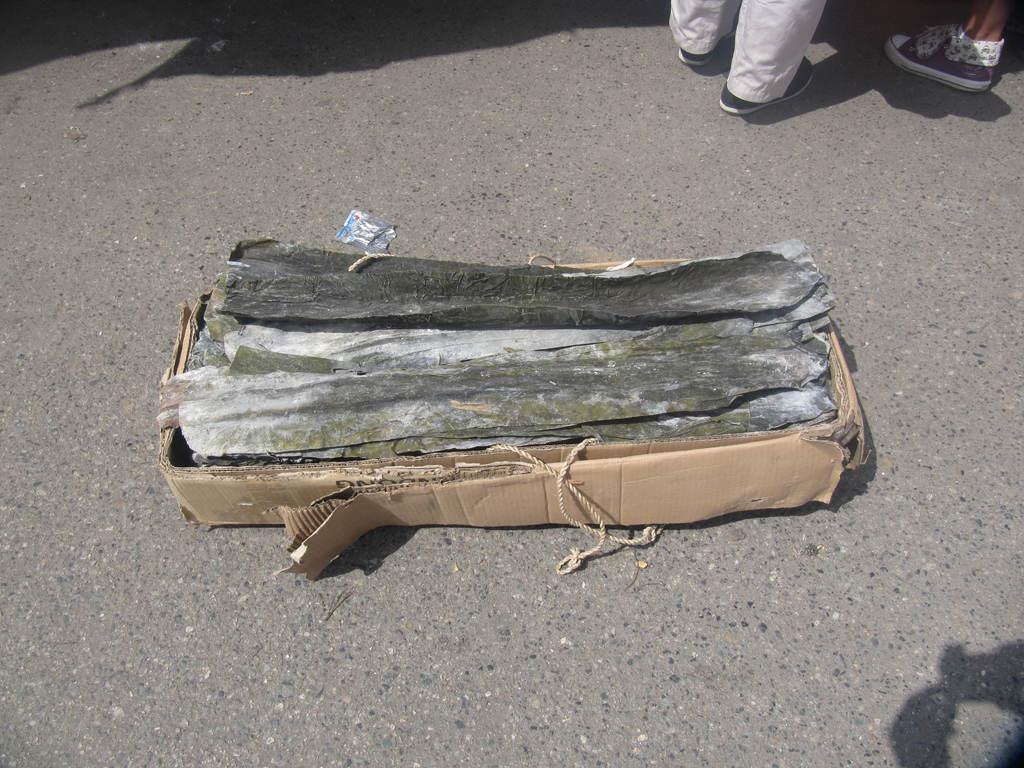Can you describe this image briefly? In this image we can see few objects and the ropes in a cardboard box which is placed on the ground. We can also see some people. 